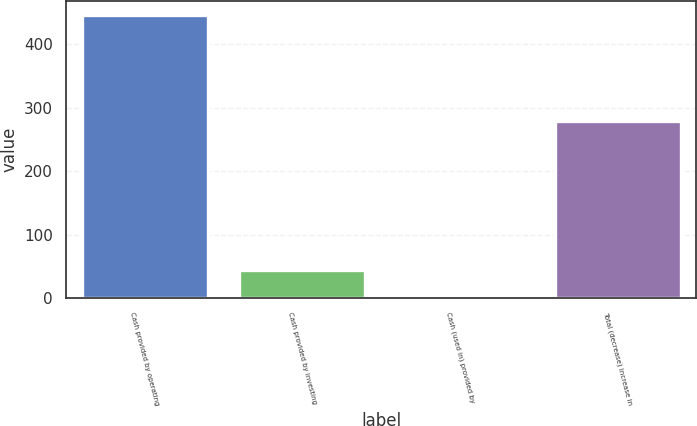Convert chart to OTSL. <chart><loc_0><loc_0><loc_500><loc_500><bar_chart><fcel>Cash provided by operating<fcel>Cash provided by investing<fcel>Cash (used in) provided by<fcel>Total (decrease) increase in<nl><fcel>446<fcel>45.5<fcel>1<fcel>280<nl></chart> 